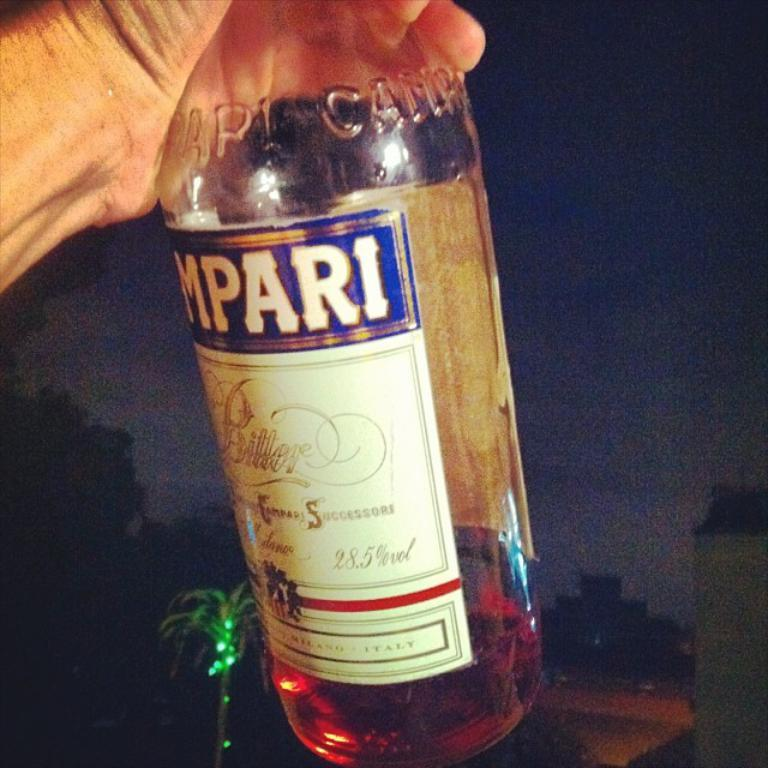<image>
Relay a brief, clear account of the picture shown. Bottle with a label that says MPARI on it. 